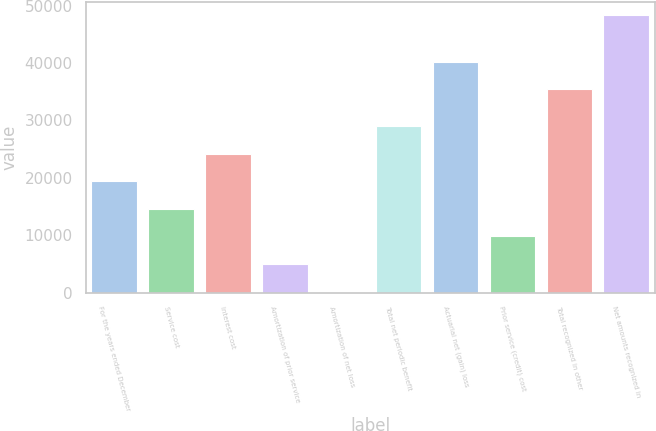Convert chart to OTSL. <chart><loc_0><loc_0><loc_500><loc_500><bar_chart><fcel>For the years ended December<fcel>Service cost<fcel>Interest cost<fcel>Amortization of prior service<fcel>Amortization of net loss<fcel>Total net periodic benefit<fcel>Actuarial net (gain) loss<fcel>Prior service (credit) cost<fcel>Total recognized in other<fcel>Net amounts recognized in<nl><fcel>19392.2<fcel>14579.4<fcel>24205<fcel>4953.8<fcel>141<fcel>29017.8<fcel>40204.8<fcel>9766.6<fcel>35392<fcel>48269<nl></chart> 